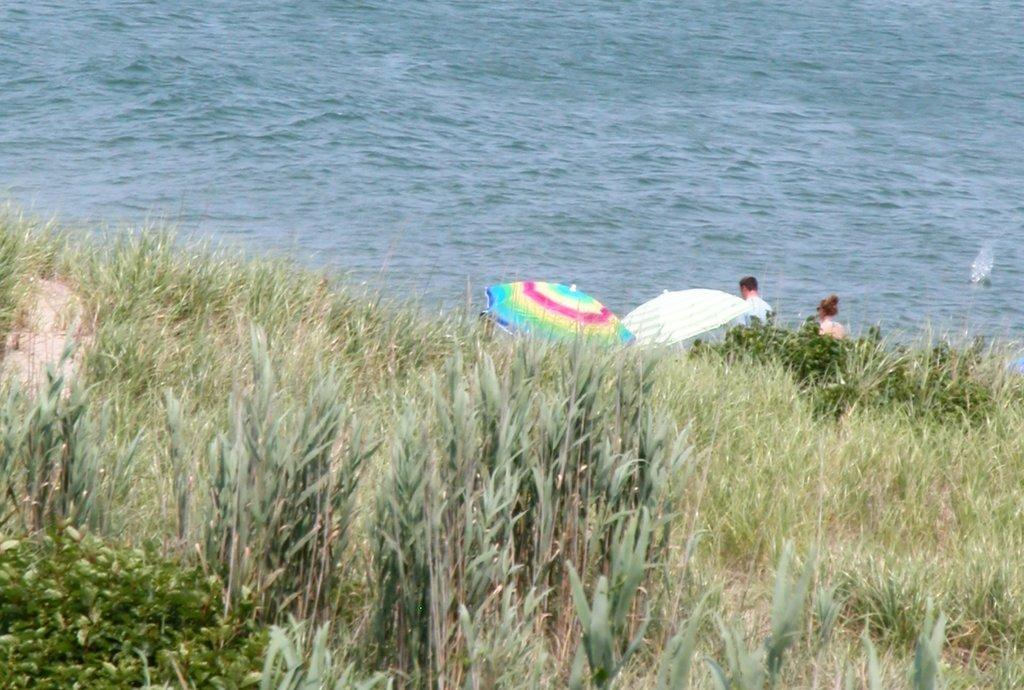What type of vegetation is in the foreground of the image? There is grass in the foreground of the image. What else can be seen in the foreground of the image? There are people standing in the foreground. What are the people holding in the image? The people are holding an umbrella. What can be seen in the background of the image? There is a river in the background of the image. What type of watch can be seen on the fowl in the image? There is no fowl or watch present in the image. What type of destruction can be seen in the image? There is no destruction present in the image; it features a peaceful scene with people, grass, an umbrella, and a river. 